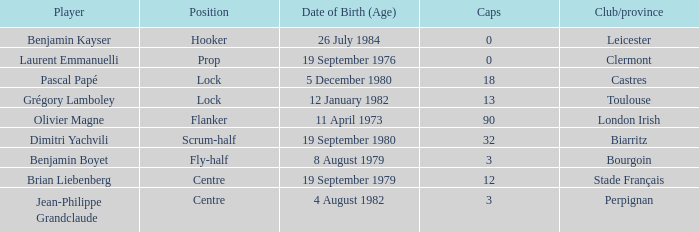Which player has a cap larger than 12 and Clubs of Toulouse? Grégory Lamboley. 